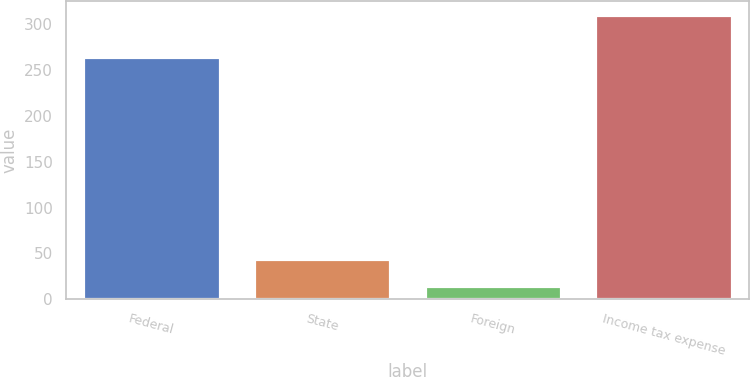Convert chart to OTSL. <chart><loc_0><loc_0><loc_500><loc_500><bar_chart><fcel>Federal<fcel>State<fcel>Foreign<fcel>Income tax expense<nl><fcel>264.1<fcel>43.66<fcel>14.1<fcel>309.7<nl></chart> 